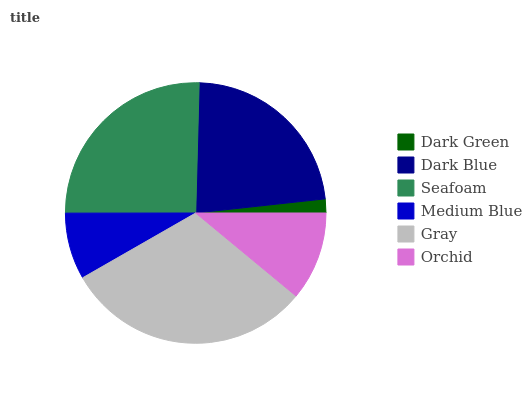Is Dark Green the minimum?
Answer yes or no. Yes. Is Gray the maximum?
Answer yes or no. Yes. Is Dark Blue the minimum?
Answer yes or no. No. Is Dark Blue the maximum?
Answer yes or no. No. Is Dark Blue greater than Dark Green?
Answer yes or no. Yes. Is Dark Green less than Dark Blue?
Answer yes or no. Yes. Is Dark Green greater than Dark Blue?
Answer yes or no. No. Is Dark Blue less than Dark Green?
Answer yes or no. No. Is Dark Blue the high median?
Answer yes or no. Yes. Is Orchid the low median?
Answer yes or no. Yes. Is Medium Blue the high median?
Answer yes or no. No. Is Seafoam the low median?
Answer yes or no. No. 